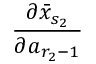Convert formula to latex. <formula><loc_0><loc_0><loc_500><loc_500>\frac { \partial \bar { x } _ { s _ { 2 } } } { \partial a _ { r _ { 2 } - 1 } }</formula> 